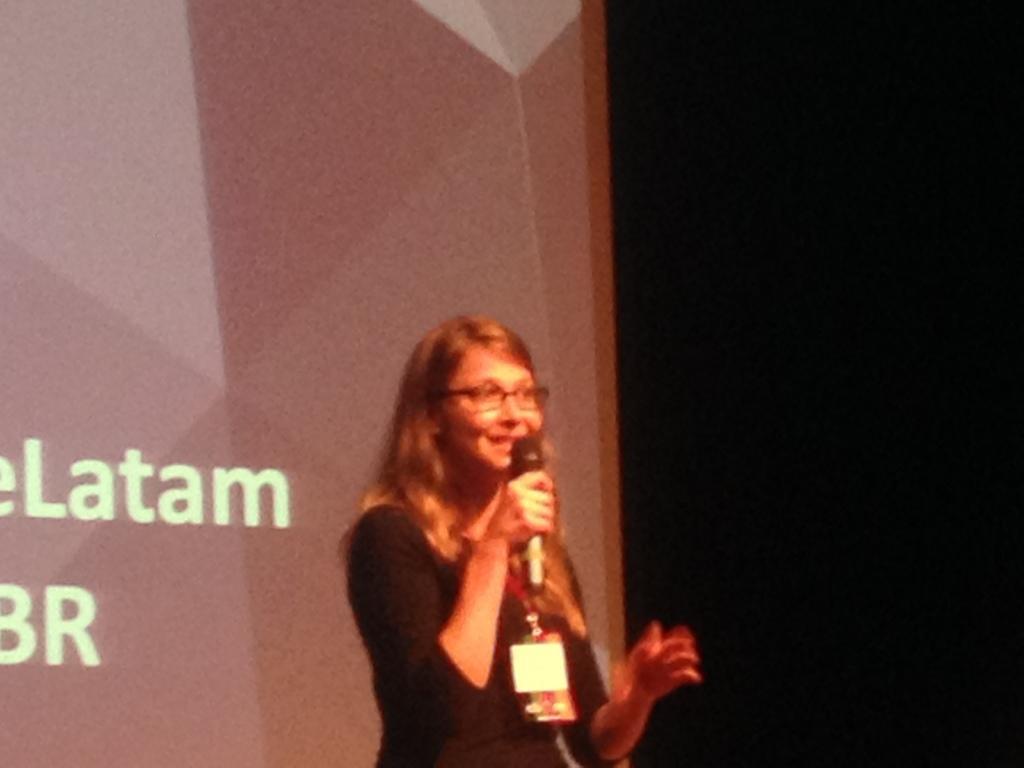In one or two sentences, can you explain what this image depicts? a person is standing wearing a black t shirt, holding a microphone in her hand. behind her at the right there is a black background. at the left there is a projector display. 